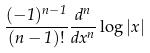<formula> <loc_0><loc_0><loc_500><loc_500>\frac { ( - 1 ) ^ { n - 1 } } { ( n - 1 ) ! } \frac { d ^ { n } } { d x ^ { n } } \log | x |</formula> 